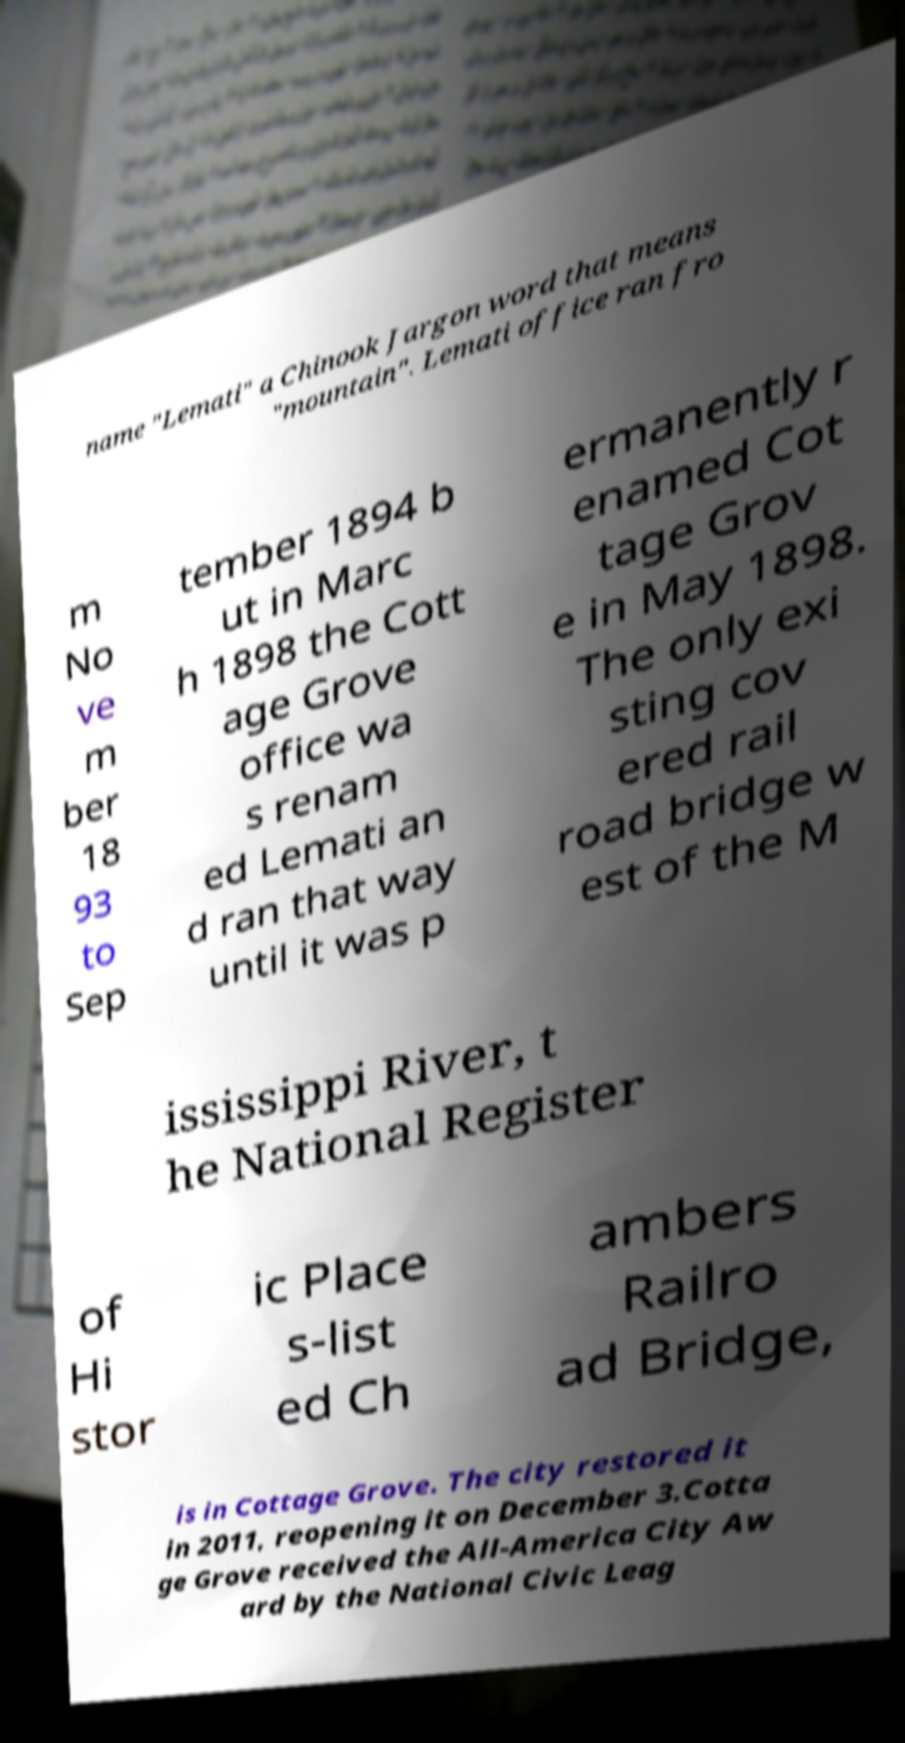There's text embedded in this image that I need extracted. Can you transcribe it verbatim? name "Lemati" a Chinook Jargon word that means "mountain". Lemati office ran fro m No ve m ber 18 93 to Sep tember 1894 b ut in Marc h 1898 the Cott age Grove office wa s renam ed Lemati an d ran that way until it was p ermanently r enamed Cot tage Grov e in May 1898. The only exi sting cov ered rail road bridge w est of the M ississippi River, t he National Register of Hi stor ic Place s-list ed Ch ambers Railro ad Bridge, is in Cottage Grove. The city restored it in 2011, reopening it on December 3.Cotta ge Grove received the All-America City Aw ard by the National Civic Leag 